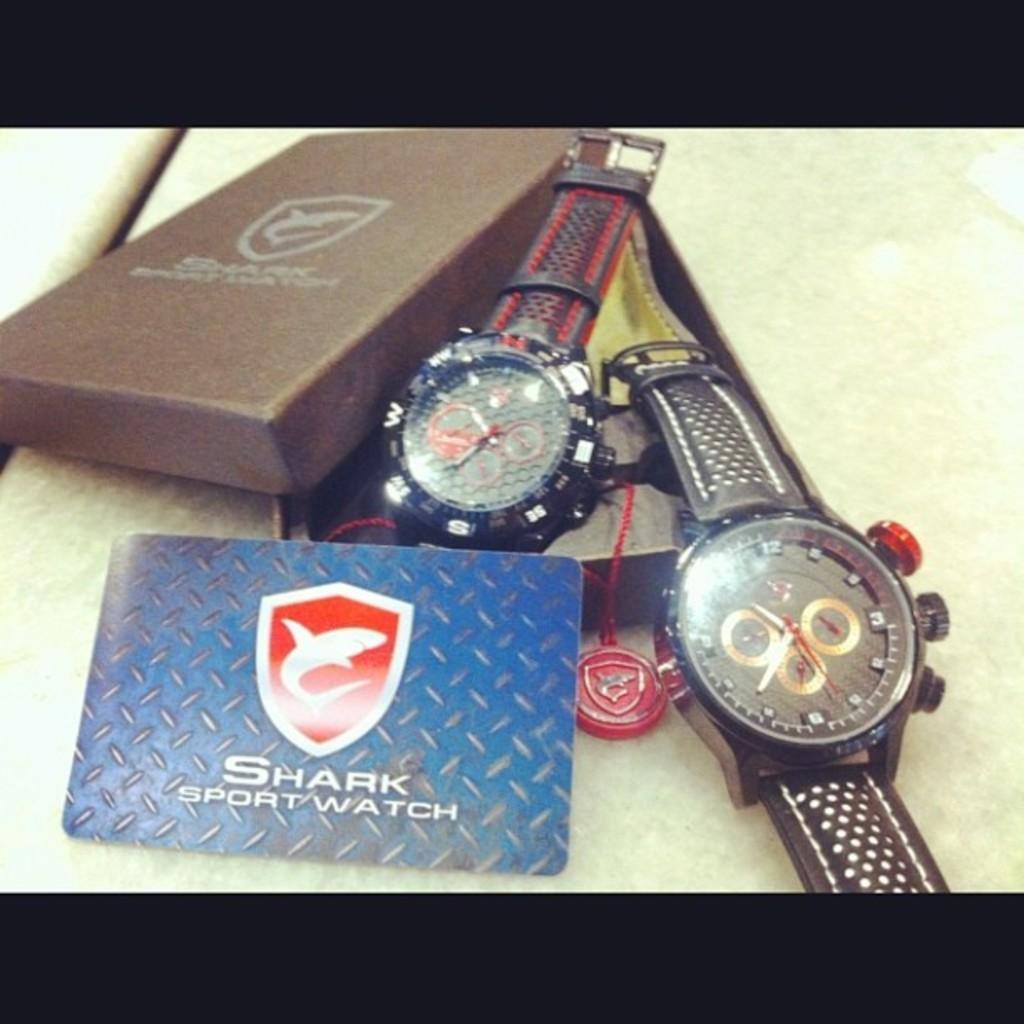<image>
Relay a brief, clear account of the picture shown. Retro looking men's Shark Sport Watches with perforated leather straps and 2 winding buttons on side, 1 push button. 